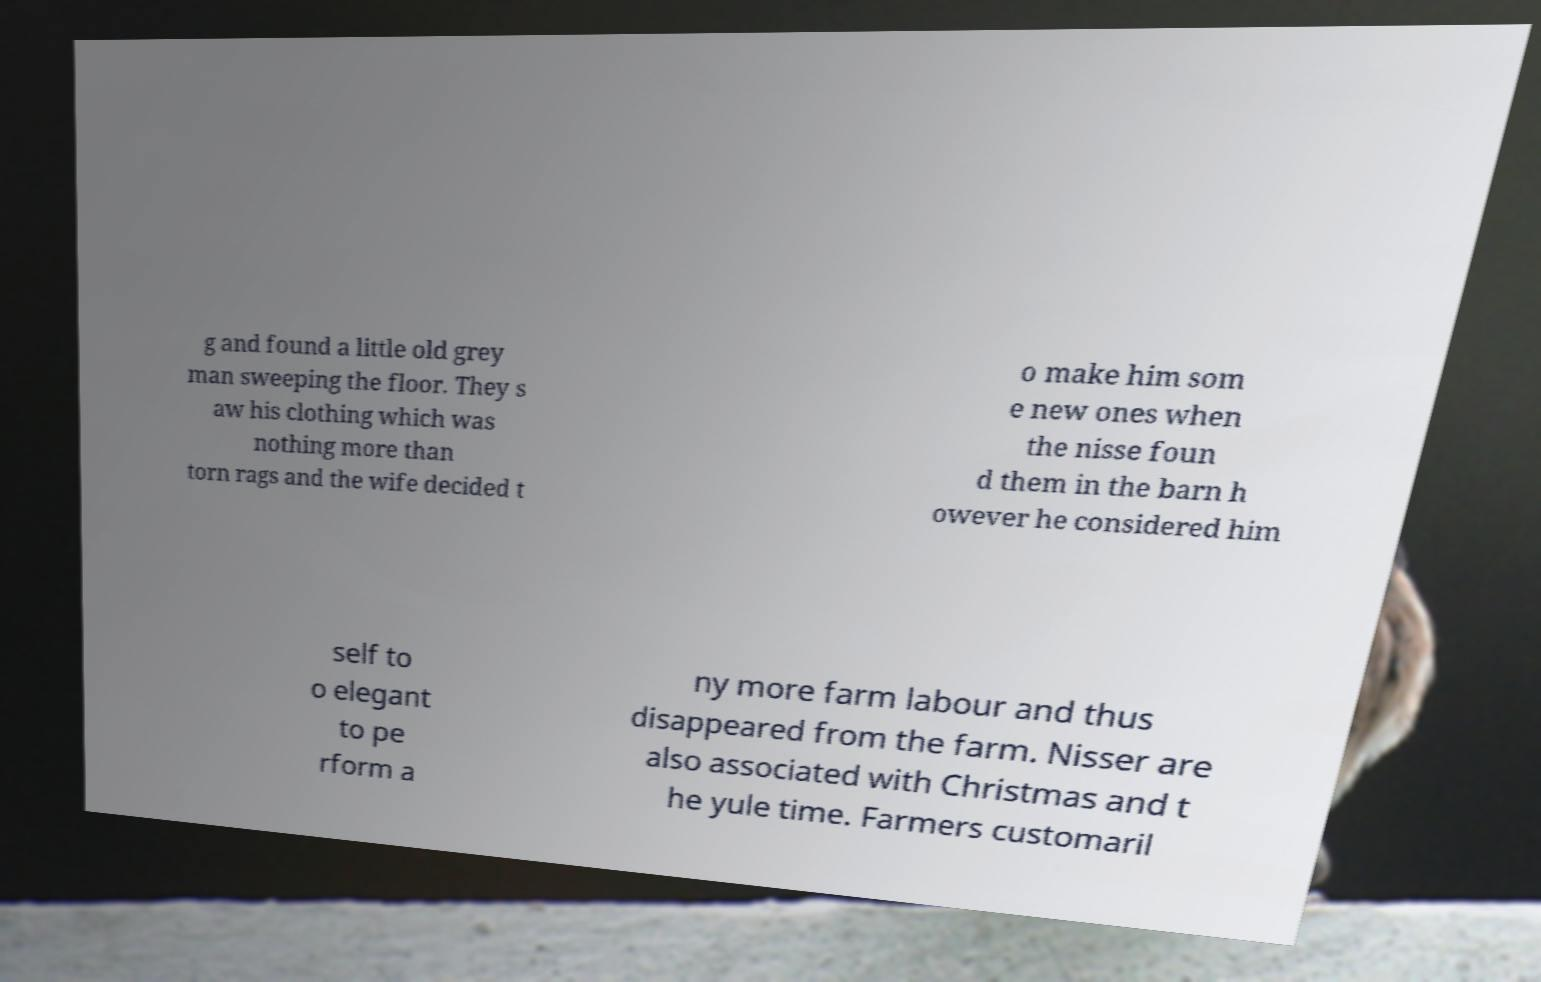There's text embedded in this image that I need extracted. Can you transcribe it verbatim? g and found a little old grey man sweeping the floor. They s aw his clothing which was nothing more than torn rags and the wife decided t o make him som e new ones when the nisse foun d them in the barn h owever he considered him self to o elegant to pe rform a ny more farm labour and thus disappeared from the farm. Nisser are also associated with Christmas and t he yule time. Farmers customaril 